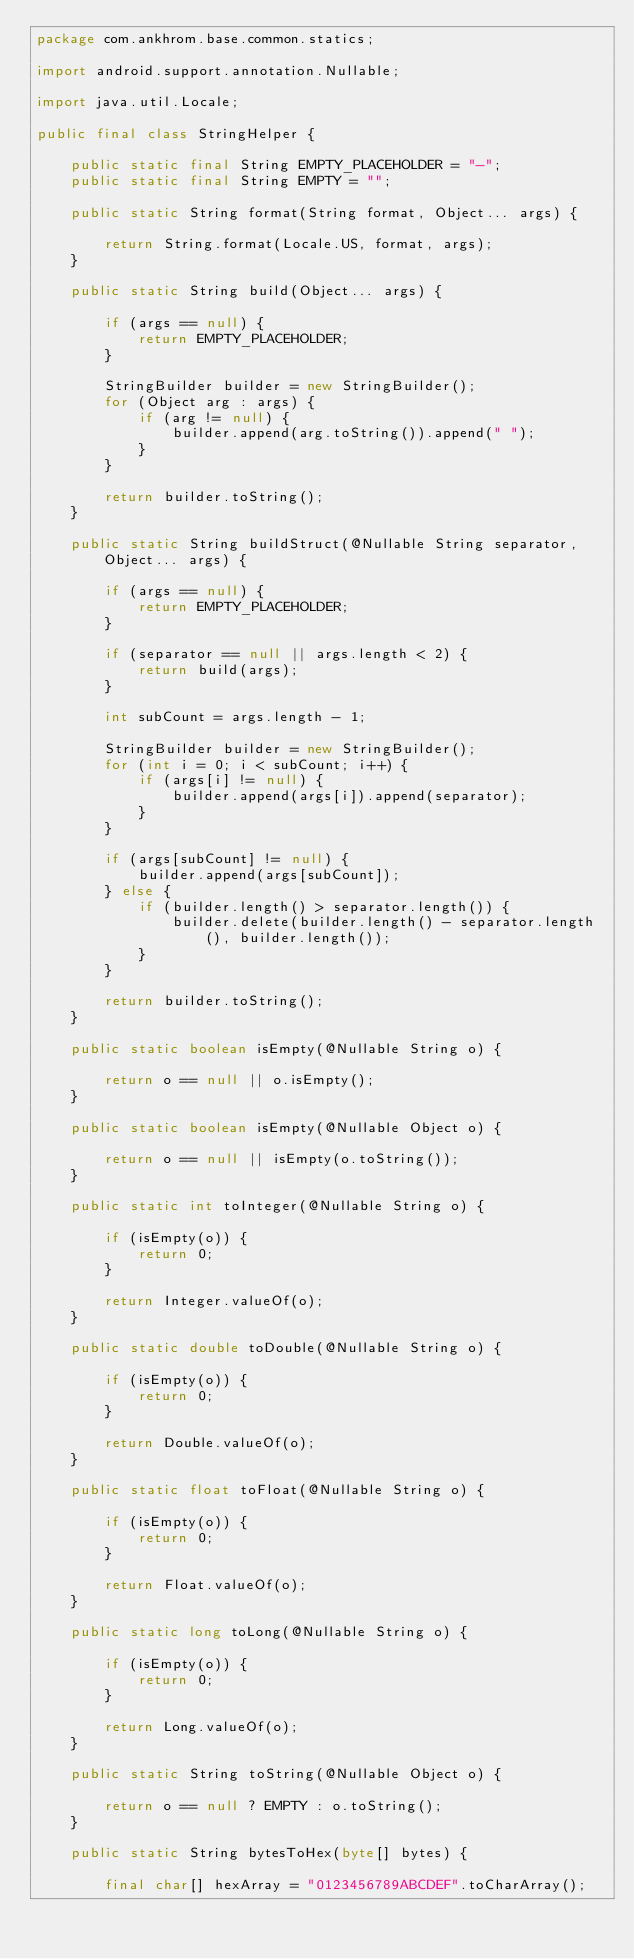<code> <loc_0><loc_0><loc_500><loc_500><_Java_>package com.ankhrom.base.common.statics;

import android.support.annotation.Nullable;

import java.util.Locale;

public final class StringHelper {

    public static final String EMPTY_PLACEHOLDER = "-";
    public static final String EMPTY = "";

    public static String format(String format, Object... args) {

        return String.format(Locale.US, format, args);
    }

    public static String build(Object... args) {

        if (args == null) {
            return EMPTY_PLACEHOLDER;
        }

        StringBuilder builder = new StringBuilder();
        for (Object arg : args) {
            if (arg != null) {
                builder.append(arg.toString()).append(" ");
            }
        }

        return builder.toString();
    }

    public static String buildStruct(@Nullable String separator, Object... args) {

        if (args == null) {
            return EMPTY_PLACEHOLDER;
        }

        if (separator == null || args.length < 2) {
            return build(args);
        }

        int subCount = args.length - 1;

        StringBuilder builder = new StringBuilder();
        for (int i = 0; i < subCount; i++) {
            if (args[i] != null) {
                builder.append(args[i]).append(separator);
            }
        }

        if (args[subCount] != null) {
            builder.append(args[subCount]);
        } else {
            if (builder.length() > separator.length()) {
                builder.delete(builder.length() - separator.length(), builder.length());
            }
        }

        return builder.toString();
    }

    public static boolean isEmpty(@Nullable String o) {

        return o == null || o.isEmpty();
    }

    public static boolean isEmpty(@Nullable Object o) {

        return o == null || isEmpty(o.toString());
    }

    public static int toInteger(@Nullable String o) {

        if (isEmpty(o)) {
            return 0;
        }

        return Integer.valueOf(o);
    }

    public static double toDouble(@Nullable String o) {

        if (isEmpty(o)) {
            return 0;
        }

        return Double.valueOf(o);
    }

    public static float toFloat(@Nullable String o) {

        if (isEmpty(o)) {
            return 0;
        }

        return Float.valueOf(o);
    }

    public static long toLong(@Nullable String o) {

        if (isEmpty(o)) {
            return 0;
        }

        return Long.valueOf(o);
    }

    public static String toString(@Nullable Object o) {

        return o == null ? EMPTY : o.toString();
    }

    public static String bytesToHex(byte[] bytes) {

        final char[] hexArray = "0123456789ABCDEF".toCharArray();
</code> 